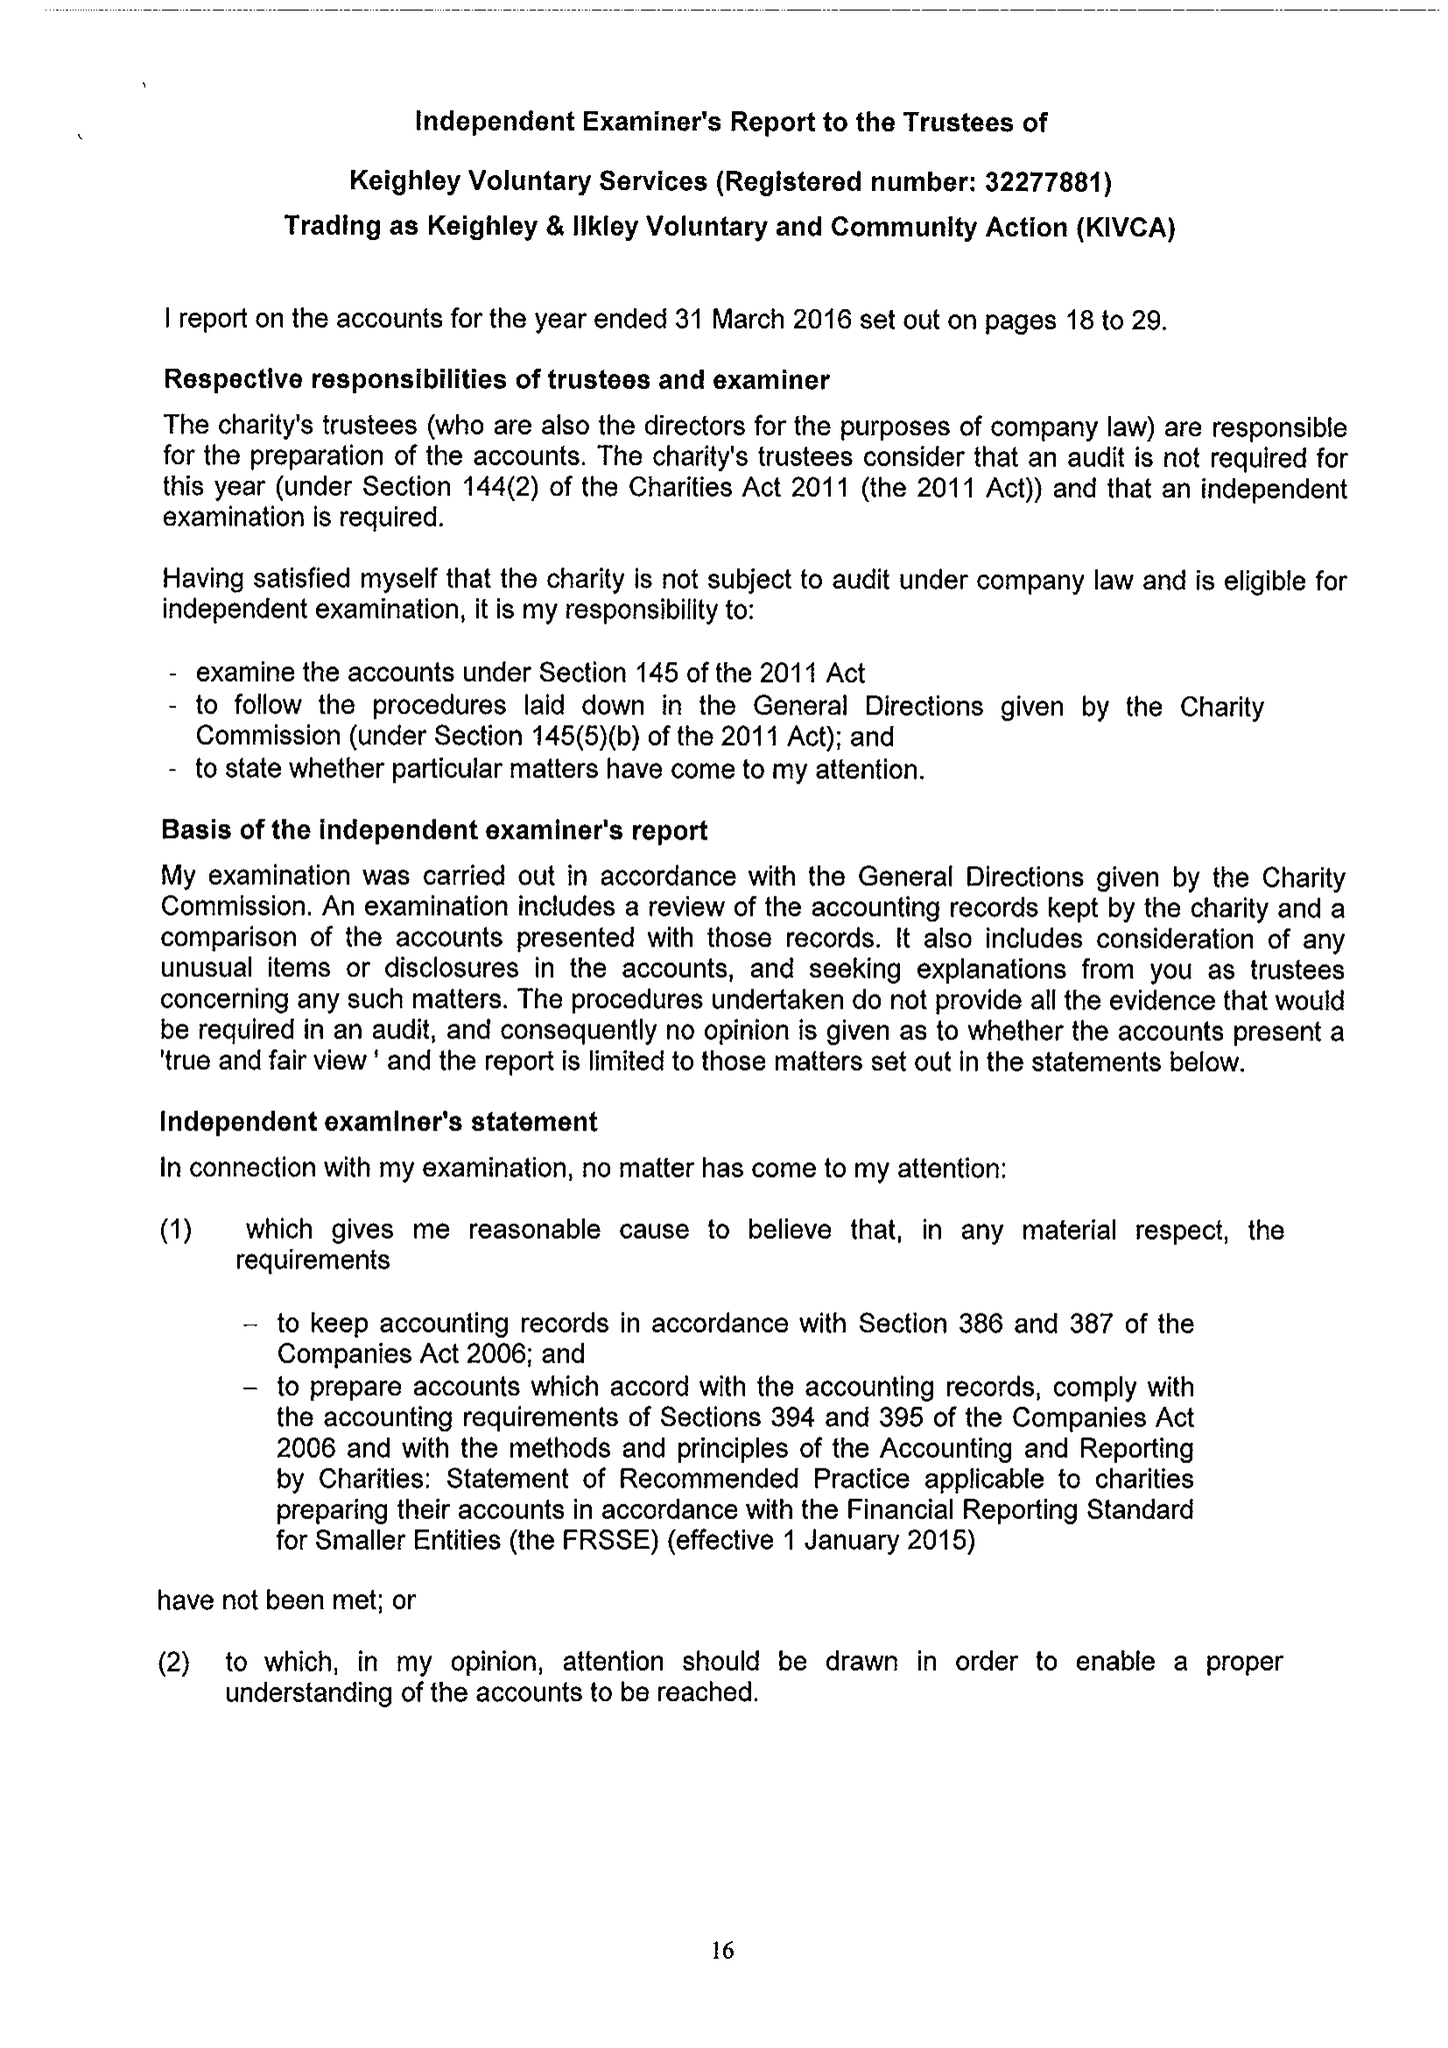What is the value for the charity_number?
Answer the question using a single word or phrase. 1061641 